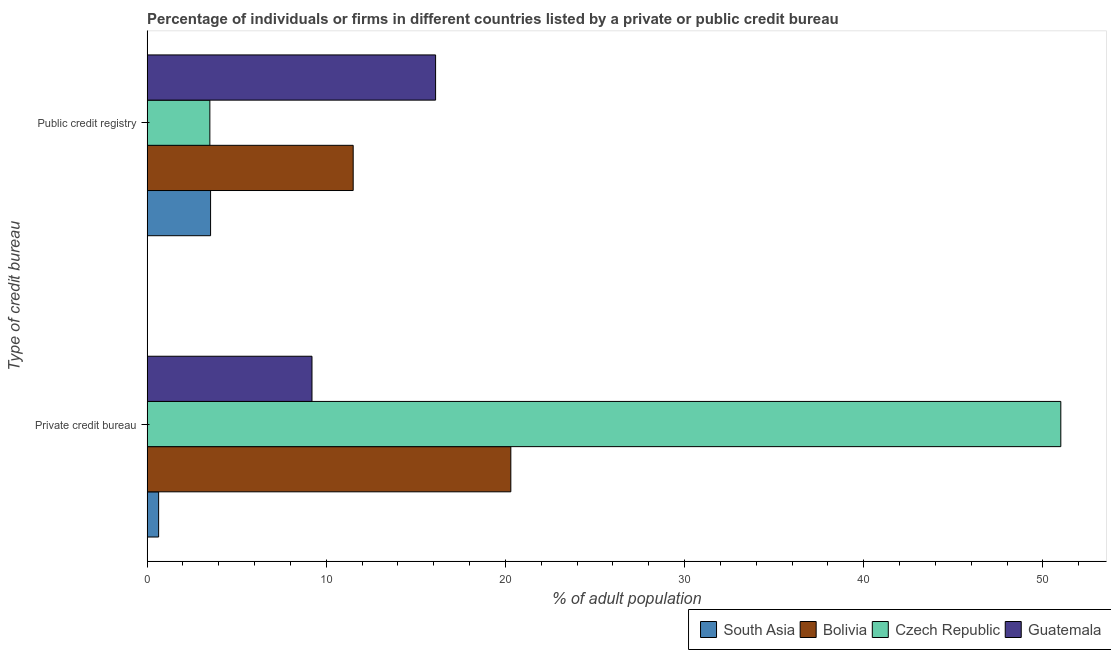How many groups of bars are there?
Your answer should be very brief. 2. Are the number of bars per tick equal to the number of legend labels?
Ensure brevity in your answer.  Yes. Are the number of bars on each tick of the Y-axis equal?
Provide a short and direct response. Yes. How many bars are there on the 2nd tick from the top?
Offer a very short reply. 4. What is the label of the 2nd group of bars from the top?
Offer a very short reply. Private credit bureau. Across all countries, what is the minimum percentage of firms listed by public credit bureau?
Provide a succinct answer. 3.5. In which country was the percentage of firms listed by public credit bureau maximum?
Your response must be concise. Guatemala. In which country was the percentage of firms listed by public credit bureau minimum?
Your answer should be very brief. Czech Republic. What is the total percentage of firms listed by private credit bureau in the graph?
Ensure brevity in your answer.  81.14. What is the difference between the percentage of firms listed by private credit bureau in Guatemala and that in Bolivia?
Give a very brief answer. -11.1. What is the difference between the percentage of firms listed by public credit bureau in Guatemala and the percentage of firms listed by private credit bureau in Czech Republic?
Make the answer very short. -34.9. What is the average percentage of firms listed by public credit bureau per country?
Your response must be concise. 8.66. What is the difference between the percentage of firms listed by public credit bureau and percentage of firms listed by private credit bureau in South Asia?
Give a very brief answer. 2.9. What is the ratio of the percentage of firms listed by private credit bureau in Guatemala to that in Bolivia?
Ensure brevity in your answer.  0.45. Is the percentage of firms listed by public credit bureau in Czech Republic less than that in Guatemala?
Give a very brief answer. Yes. In how many countries, is the percentage of firms listed by public credit bureau greater than the average percentage of firms listed by public credit bureau taken over all countries?
Your answer should be compact. 2. What does the 1st bar from the top in Public credit registry represents?
Your answer should be very brief. Guatemala. What does the 3rd bar from the bottom in Public credit registry represents?
Make the answer very short. Czech Republic. Are all the bars in the graph horizontal?
Offer a terse response. Yes. How many countries are there in the graph?
Provide a short and direct response. 4. Are the values on the major ticks of X-axis written in scientific E-notation?
Your response must be concise. No. Does the graph contain any zero values?
Your answer should be very brief. No. Does the graph contain grids?
Ensure brevity in your answer.  No. Where does the legend appear in the graph?
Provide a succinct answer. Bottom right. How are the legend labels stacked?
Your answer should be very brief. Horizontal. What is the title of the graph?
Give a very brief answer. Percentage of individuals or firms in different countries listed by a private or public credit bureau. Does "Colombia" appear as one of the legend labels in the graph?
Offer a terse response. No. What is the label or title of the X-axis?
Provide a succinct answer. % of adult population. What is the label or title of the Y-axis?
Your response must be concise. Type of credit bureau. What is the % of adult population of South Asia in Private credit bureau?
Offer a very short reply. 0.64. What is the % of adult population in Bolivia in Private credit bureau?
Give a very brief answer. 20.3. What is the % of adult population in South Asia in Public credit registry?
Provide a succinct answer. 3.54. What is the % of adult population of Bolivia in Public credit registry?
Offer a very short reply. 11.5. What is the % of adult population in Czech Republic in Public credit registry?
Offer a very short reply. 3.5. Across all Type of credit bureau, what is the maximum % of adult population in South Asia?
Offer a terse response. 3.54. Across all Type of credit bureau, what is the maximum % of adult population in Bolivia?
Your answer should be very brief. 20.3. Across all Type of credit bureau, what is the maximum % of adult population in Czech Republic?
Provide a succinct answer. 51. Across all Type of credit bureau, what is the maximum % of adult population of Guatemala?
Provide a short and direct response. 16.1. Across all Type of credit bureau, what is the minimum % of adult population in South Asia?
Provide a short and direct response. 0.64. Across all Type of credit bureau, what is the minimum % of adult population in Bolivia?
Offer a very short reply. 11.5. Across all Type of credit bureau, what is the minimum % of adult population in Guatemala?
Give a very brief answer. 9.2. What is the total % of adult population in South Asia in the graph?
Give a very brief answer. 4.18. What is the total % of adult population of Bolivia in the graph?
Offer a very short reply. 31.8. What is the total % of adult population in Czech Republic in the graph?
Make the answer very short. 54.5. What is the total % of adult population in Guatemala in the graph?
Offer a very short reply. 25.3. What is the difference between the % of adult population of Bolivia in Private credit bureau and that in Public credit registry?
Provide a short and direct response. 8.8. What is the difference between the % of adult population in Czech Republic in Private credit bureau and that in Public credit registry?
Your answer should be compact. 47.5. What is the difference between the % of adult population of Guatemala in Private credit bureau and that in Public credit registry?
Provide a short and direct response. -6.9. What is the difference between the % of adult population of South Asia in Private credit bureau and the % of adult population of Bolivia in Public credit registry?
Keep it short and to the point. -10.86. What is the difference between the % of adult population of South Asia in Private credit bureau and the % of adult population of Czech Republic in Public credit registry?
Give a very brief answer. -2.86. What is the difference between the % of adult population of South Asia in Private credit bureau and the % of adult population of Guatemala in Public credit registry?
Offer a very short reply. -15.46. What is the difference between the % of adult population of Bolivia in Private credit bureau and the % of adult population of Czech Republic in Public credit registry?
Offer a terse response. 16.8. What is the difference between the % of adult population in Czech Republic in Private credit bureau and the % of adult population in Guatemala in Public credit registry?
Offer a terse response. 34.9. What is the average % of adult population of South Asia per Type of credit bureau?
Provide a succinct answer. 2.09. What is the average % of adult population of Czech Republic per Type of credit bureau?
Provide a succinct answer. 27.25. What is the average % of adult population in Guatemala per Type of credit bureau?
Your answer should be very brief. 12.65. What is the difference between the % of adult population in South Asia and % of adult population in Bolivia in Private credit bureau?
Your response must be concise. -19.66. What is the difference between the % of adult population of South Asia and % of adult population of Czech Republic in Private credit bureau?
Your response must be concise. -50.36. What is the difference between the % of adult population in South Asia and % of adult population in Guatemala in Private credit bureau?
Offer a very short reply. -8.56. What is the difference between the % of adult population of Bolivia and % of adult population of Czech Republic in Private credit bureau?
Your answer should be very brief. -30.7. What is the difference between the % of adult population of Czech Republic and % of adult population of Guatemala in Private credit bureau?
Provide a succinct answer. 41.8. What is the difference between the % of adult population in South Asia and % of adult population in Bolivia in Public credit registry?
Offer a terse response. -7.96. What is the difference between the % of adult population in South Asia and % of adult population in Czech Republic in Public credit registry?
Provide a short and direct response. 0.04. What is the difference between the % of adult population in South Asia and % of adult population in Guatemala in Public credit registry?
Your answer should be very brief. -12.56. What is the difference between the % of adult population in Bolivia and % of adult population in Czech Republic in Public credit registry?
Your answer should be very brief. 8. What is the difference between the % of adult population in Bolivia and % of adult population in Guatemala in Public credit registry?
Your answer should be compact. -4.6. What is the ratio of the % of adult population in South Asia in Private credit bureau to that in Public credit registry?
Keep it short and to the point. 0.18. What is the ratio of the % of adult population of Bolivia in Private credit bureau to that in Public credit registry?
Make the answer very short. 1.77. What is the ratio of the % of adult population of Czech Republic in Private credit bureau to that in Public credit registry?
Keep it short and to the point. 14.57. What is the difference between the highest and the second highest % of adult population of South Asia?
Offer a very short reply. 2.9. What is the difference between the highest and the second highest % of adult population of Czech Republic?
Your response must be concise. 47.5. What is the difference between the highest and the second highest % of adult population in Guatemala?
Make the answer very short. 6.9. What is the difference between the highest and the lowest % of adult population of South Asia?
Keep it short and to the point. 2.9. What is the difference between the highest and the lowest % of adult population of Bolivia?
Offer a terse response. 8.8. What is the difference between the highest and the lowest % of adult population in Czech Republic?
Provide a short and direct response. 47.5. 